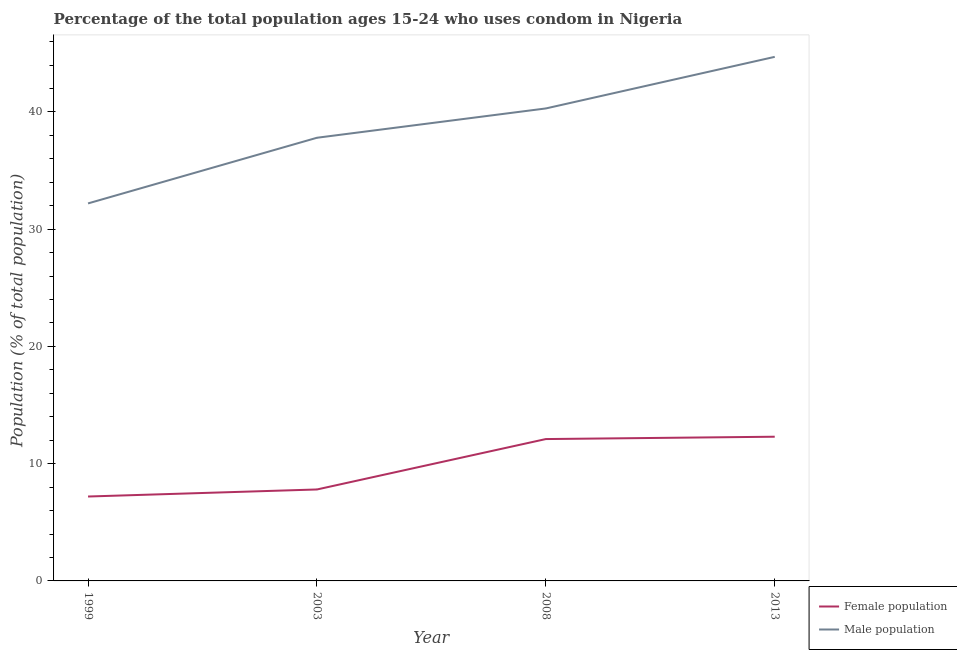Does the line corresponding to female population intersect with the line corresponding to male population?
Ensure brevity in your answer.  No. Is the number of lines equal to the number of legend labels?
Give a very brief answer. Yes. Across all years, what is the minimum female population?
Give a very brief answer. 7.2. In which year was the male population minimum?
Offer a terse response. 1999. What is the total female population in the graph?
Provide a short and direct response. 39.4. What is the difference between the female population in 1999 and that in 2013?
Offer a terse response. -5.1. What is the difference between the male population in 2013 and the female population in 2008?
Ensure brevity in your answer.  32.6. What is the average female population per year?
Make the answer very short. 9.85. In the year 1999, what is the difference between the male population and female population?
Your response must be concise. 25. What is the ratio of the male population in 1999 to that in 2008?
Give a very brief answer. 0.8. What is the difference between the highest and the second highest female population?
Offer a terse response. 0.2. What is the difference between the highest and the lowest female population?
Ensure brevity in your answer.  5.1. Is the sum of the female population in 2003 and 2008 greater than the maximum male population across all years?
Keep it short and to the point. No. Does the male population monotonically increase over the years?
Provide a succinct answer. Yes. Is the female population strictly greater than the male population over the years?
Offer a terse response. No. How many lines are there?
Give a very brief answer. 2. How many years are there in the graph?
Provide a succinct answer. 4. What is the difference between two consecutive major ticks on the Y-axis?
Keep it short and to the point. 10. Does the graph contain grids?
Provide a short and direct response. No. How are the legend labels stacked?
Keep it short and to the point. Vertical. What is the title of the graph?
Your answer should be very brief. Percentage of the total population ages 15-24 who uses condom in Nigeria. Does "current US$" appear as one of the legend labels in the graph?
Make the answer very short. No. What is the label or title of the Y-axis?
Offer a very short reply. Population (% of total population) . What is the Population (% of total population)  of Female population in 1999?
Provide a succinct answer. 7.2. What is the Population (% of total population)  of Male population in 1999?
Your answer should be very brief. 32.2. What is the Population (% of total population)  in Male population in 2003?
Your response must be concise. 37.8. What is the Population (% of total population)  of Female population in 2008?
Provide a succinct answer. 12.1. What is the Population (% of total population)  of Male population in 2008?
Provide a succinct answer. 40.3. What is the Population (% of total population)  of Female population in 2013?
Offer a very short reply. 12.3. What is the Population (% of total population)  in Male population in 2013?
Ensure brevity in your answer.  44.7. Across all years, what is the maximum Population (% of total population)  in Female population?
Give a very brief answer. 12.3. Across all years, what is the maximum Population (% of total population)  in Male population?
Your answer should be compact. 44.7. Across all years, what is the minimum Population (% of total population)  of Male population?
Your response must be concise. 32.2. What is the total Population (% of total population)  in Female population in the graph?
Your answer should be compact. 39.4. What is the total Population (% of total population)  of Male population in the graph?
Your answer should be very brief. 155. What is the difference between the Population (% of total population)  of Male population in 1999 and that in 2003?
Provide a succinct answer. -5.6. What is the difference between the Population (% of total population)  in Female population in 1999 and that in 2008?
Your response must be concise. -4.9. What is the difference between the Population (% of total population)  of Female population in 2003 and that in 2008?
Offer a terse response. -4.3. What is the difference between the Population (% of total population)  of Male population in 2003 and that in 2008?
Your answer should be very brief. -2.5. What is the difference between the Population (% of total population)  of Female population in 2003 and that in 2013?
Offer a terse response. -4.5. What is the difference between the Population (% of total population)  of Female population in 2008 and that in 2013?
Provide a succinct answer. -0.2. What is the difference between the Population (% of total population)  in Male population in 2008 and that in 2013?
Offer a very short reply. -4.4. What is the difference between the Population (% of total population)  of Female population in 1999 and the Population (% of total population)  of Male population in 2003?
Keep it short and to the point. -30.6. What is the difference between the Population (% of total population)  of Female population in 1999 and the Population (% of total population)  of Male population in 2008?
Ensure brevity in your answer.  -33.1. What is the difference between the Population (% of total population)  of Female population in 1999 and the Population (% of total population)  of Male population in 2013?
Offer a very short reply. -37.5. What is the difference between the Population (% of total population)  in Female population in 2003 and the Population (% of total population)  in Male population in 2008?
Offer a very short reply. -32.5. What is the difference between the Population (% of total population)  in Female population in 2003 and the Population (% of total population)  in Male population in 2013?
Your answer should be compact. -36.9. What is the difference between the Population (% of total population)  in Female population in 2008 and the Population (% of total population)  in Male population in 2013?
Provide a succinct answer. -32.6. What is the average Population (% of total population)  in Female population per year?
Ensure brevity in your answer.  9.85. What is the average Population (% of total population)  in Male population per year?
Your response must be concise. 38.75. In the year 2008, what is the difference between the Population (% of total population)  in Female population and Population (% of total population)  in Male population?
Your answer should be very brief. -28.2. In the year 2013, what is the difference between the Population (% of total population)  of Female population and Population (% of total population)  of Male population?
Your answer should be very brief. -32.4. What is the ratio of the Population (% of total population)  in Male population in 1999 to that in 2003?
Your answer should be very brief. 0.85. What is the ratio of the Population (% of total population)  in Female population in 1999 to that in 2008?
Your answer should be very brief. 0.59. What is the ratio of the Population (% of total population)  of Male population in 1999 to that in 2008?
Your response must be concise. 0.8. What is the ratio of the Population (% of total population)  in Female population in 1999 to that in 2013?
Make the answer very short. 0.59. What is the ratio of the Population (% of total population)  of Male population in 1999 to that in 2013?
Make the answer very short. 0.72. What is the ratio of the Population (% of total population)  in Female population in 2003 to that in 2008?
Ensure brevity in your answer.  0.64. What is the ratio of the Population (% of total population)  of Male population in 2003 to that in 2008?
Your answer should be compact. 0.94. What is the ratio of the Population (% of total population)  in Female population in 2003 to that in 2013?
Provide a succinct answer. 0.63. What is the ratio of the Population (% of total population)  in Male population in 2003 to that in 2013?
Keep it short and to the point. 0.85. What is the ratio of the Population (% of total population)  of Female population in 2008 to that in 2013?
Provide a succinct answer. 0.98. What is the ratio of the Population (% of total population)  of Male population in 2008 to that in 2013?
Offer a very short reply. 0.9. What is the difference between the highest and the second highest Population (% of total population)  in Female population?
Provide a succinct answer. 0.2. What is the difference between the highest and the lowest Population (% of total population)  of Male population?
Make the answer very short. 12.5. 